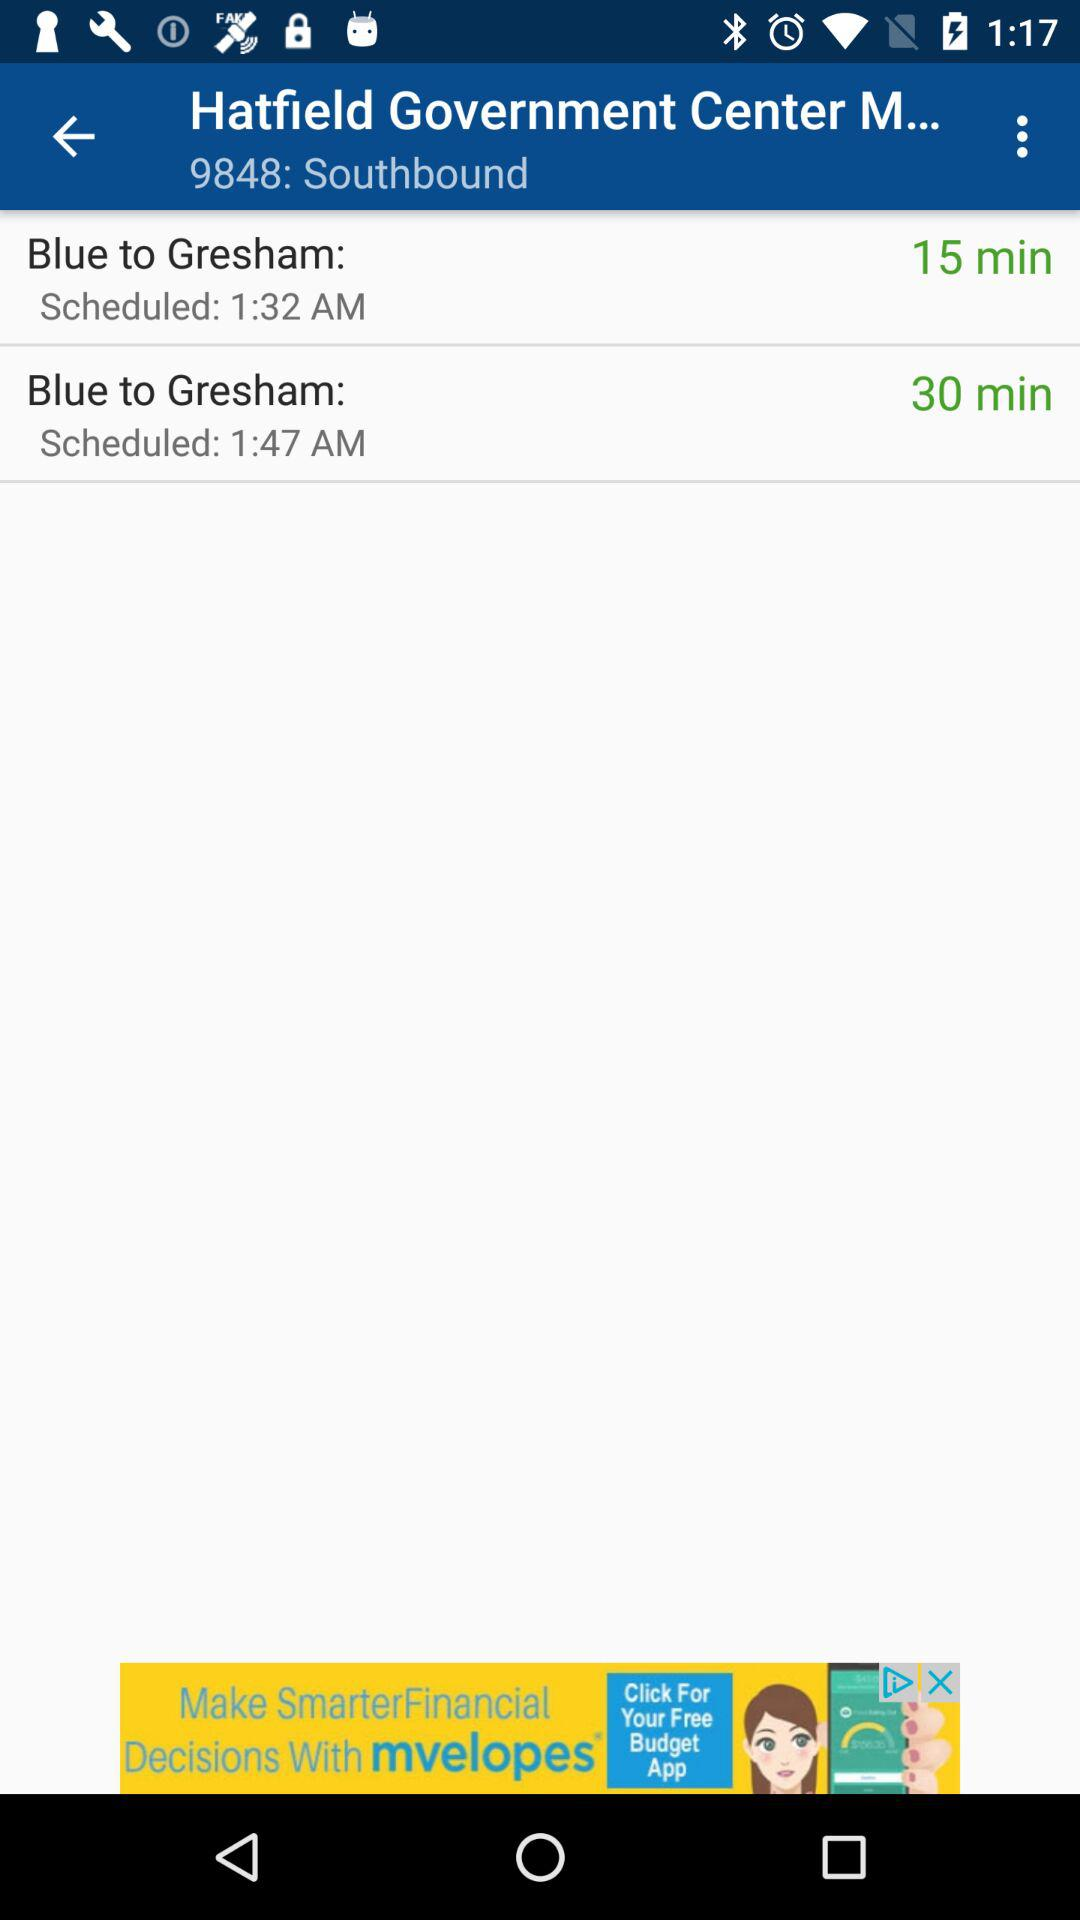What is the duration of "Blue to Gresham" at 1:47 am? The duration is 30 minutes. 